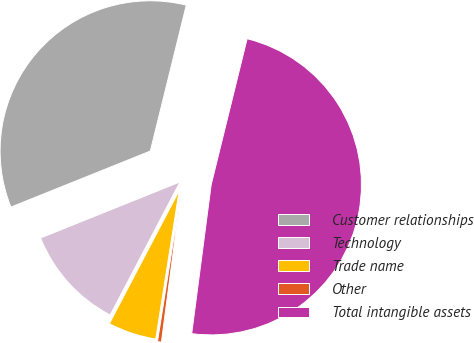<chart> <loc_0><loc_0><loc_500><loc_500><pie_chart><fcel>Customer relationships<fcel>Technology<fcel>Trade name<fcel>Other<fcel>Total intangible assets<nl><fcel>34.93%<fcel>11.23%<fcel>5.2%<fcel>0.42%<fcel>48.23%<nl></chart> 